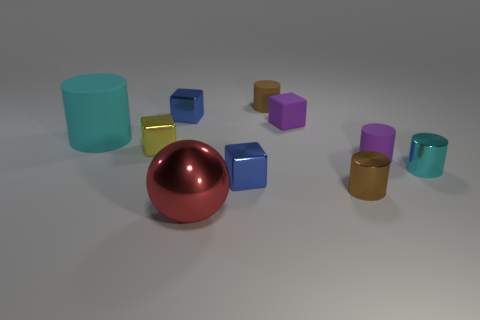There is a cylinder that is in front of the purple rubber cylinder and behind the tiny brown metal thing; what material is it?
Keep it short and to the point. Metal. What color is the ball?
Your response must be concise. Red. How many purple things have the same shape as the tiny yellow thing?
Your response must be concise. 1. Are the cylinder that is to the left of the tiny brown matte cylinder and the thing in front of the small brown metallic cylinder made of the same material?
Offer a very short reply. No. How big is the brown object left of the small block right of the small brown rubber cylinder?
Ensure brevity in your answer.  Small. There is a tiny purple object that is the same shape as the brown matte thing; what is its material?
Ensure brevity in your answer.  Rubber. There is a small blue metal thing that is to the right of the big red metallic object; does it have the same shape as the tiny purple object left of the purple matte cylinder?
Your response must be concise. Yes. Is the number of purple blocks greater than the number of cyan objects?
Give a very brief answer. No. What is the size of the purple rubber cube?
Provide a succinct answer. Small. What number of other objects are there of the same color as the large cylinder?
Offer a terse response. 1. 